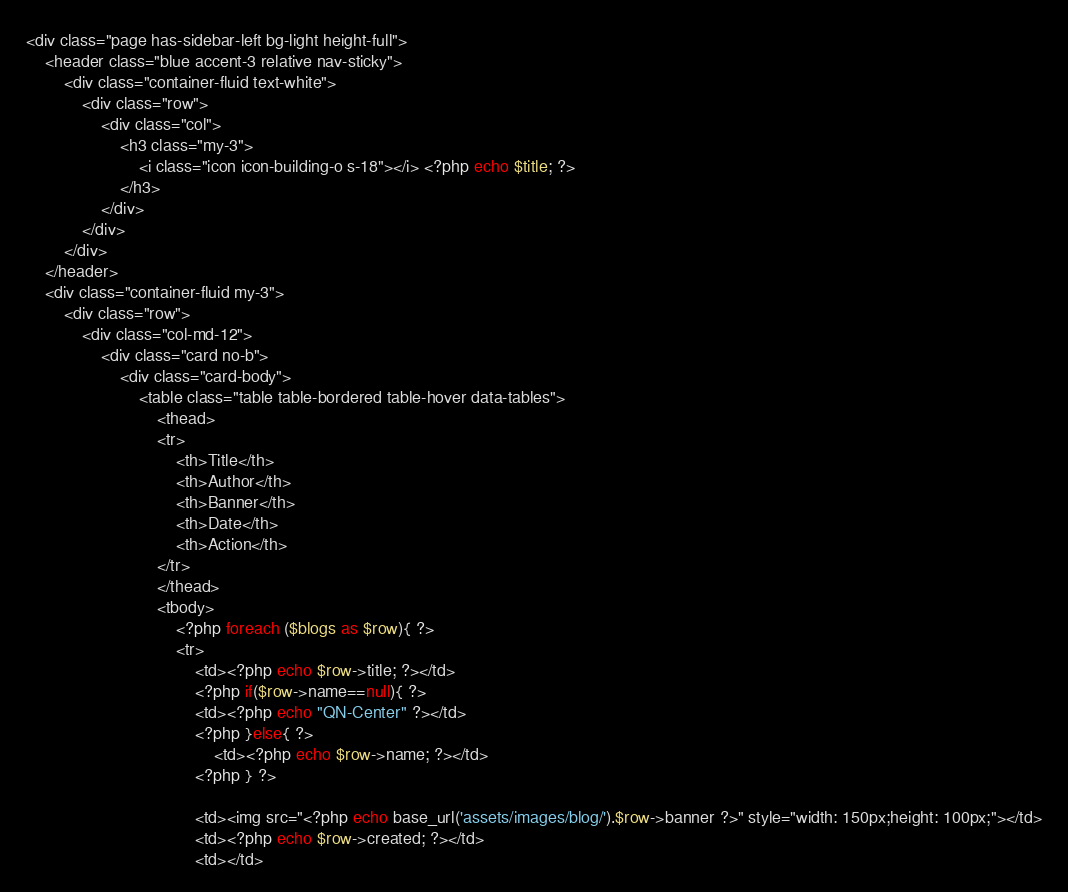<code> <loc_0><loc_0><loc_500><loc_500><_PHP_><div class="page has-sidebar-left bg-light height-full">
	<header class="blue accent-3 relative nav-sticky">
		<div class="container-fluid text-white">
			<div class="row">
				<div class="col">
					<h3 class="my-3">
						<i class="icon icon-building-o s-18"></i> <?php echo $title; ?>
					</h3>
				</div>
			</div>
		</div>
	</header>
	<div class="container-fluid my-3">
		<div class="row">
			<div class="col-md-12">
				<div class="card no-b">
					<div class="card-body">
						<table class="table table-bordered table-hover data-tables">
							<thead>
							<tr>
								<th>Title</th>
								<th>Author</th>
								<th>Banner</th>
								<th>Date</th>
								<th>Action</th>
							</tr>
							</thead>
							<tbody>
								<?php foreach ($blogs as $row){ ?>
								<tr>
									<td><?php echo $row->title; ?></td>
									<?php if($row->name==null){ ?>
									<td><?php echo "QN-Center" ?></td>
									<?php }else{ ?>
										<td><?php echo $row->name; ?></td>
									<?php } ?>
									
									<td><img src="<?php echo base_url('assets/images/blog/').$row->banner ?>" style="width: 150px;height: 100px;"></td>
									<td><?php echo $row->created; ?></td>
									<td></td></code> 